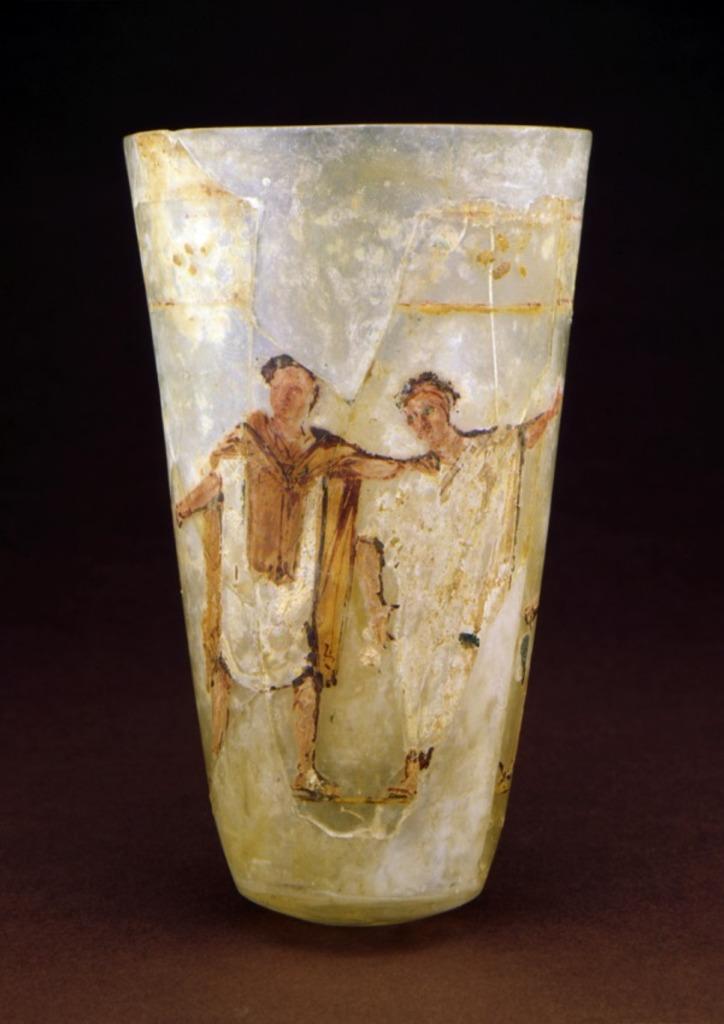Can you describe this image briefly? There is a glass on which, there is a painting, on the table. In the painting, there are persons standing on the ground. The background is dark in color. 